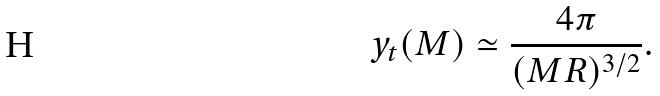Convert formula to latex. <formula><loc_0><loc_0><loc_500><loc_500>y _ { t } ( M ) \simeq { \frac { 4 \pi } { ( M R ) ^ { 3 / 2 } } } .</formula> 